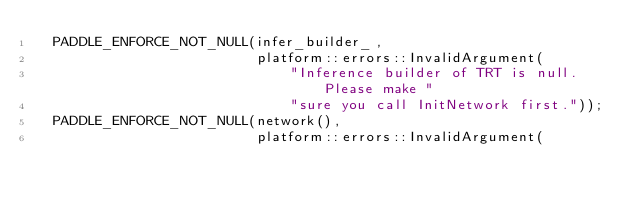<code> <loc_0><loc_0><loc_500><loc_500><_C++_>  PADDLE_ENFORCE_NOT_NULL(infer_builder_,
                          platform::errors::InvalidArgument(
                              "Inference builder of TRT is null. Please make "
                              "sure you call InitNetwork first."));
  PADDLE_ENFORCE_NOT_NULL(network(),
                          platform::errors::InvalidArgument(</code> 